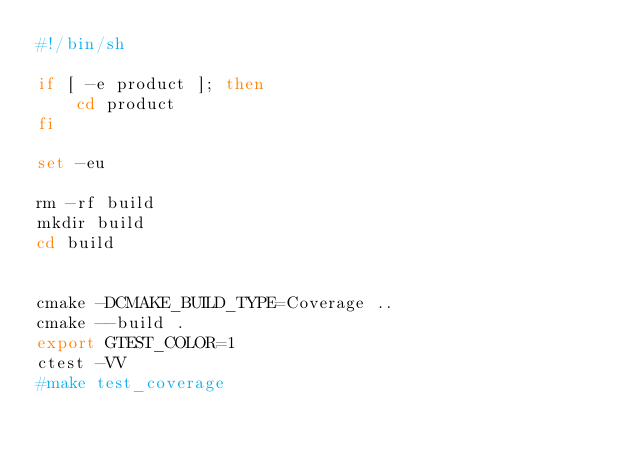<code> <loc_0><loc_0><loc_500><loc_500><_Bash_>#!/bin/sh

if [ -e product ]; then
    cd product
fi

set -eu

rm -rf build
mkdir build
cd build


cmake -DCMAKE_BUILD_TYPE=Coverage ..
cmake --build .
export GTEST_COLOR=1
ctest -VV
#make test_coverage
</code> 